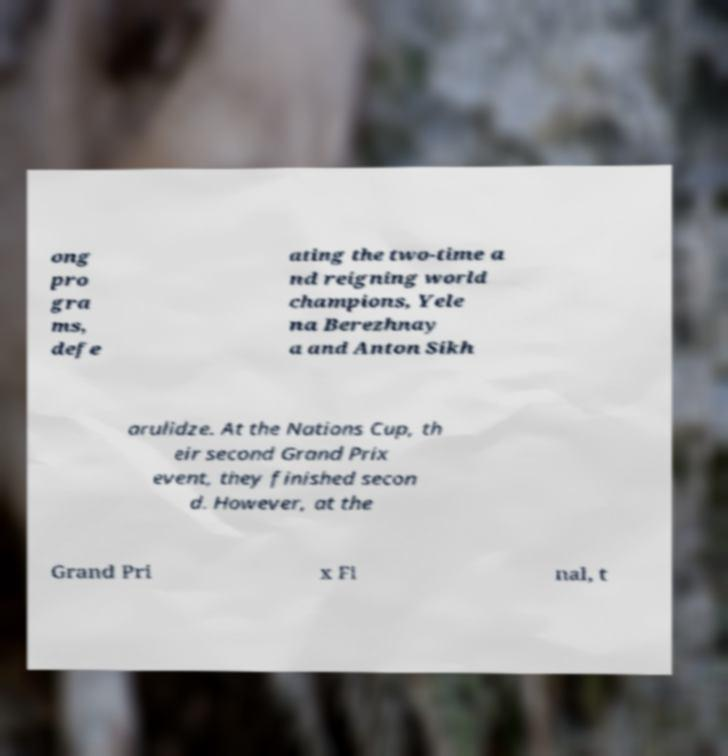Please identify and transcribe the text found in this image. ong pro gra ms, defe ating the two-time a nd reigning world champions, Yele na Berezhnay a and Anton Sikh arulidze. At the Nations Cup, th eir second Grand Prix event, they finished secon d. However, at the Grand Pri x Fi nal, t 